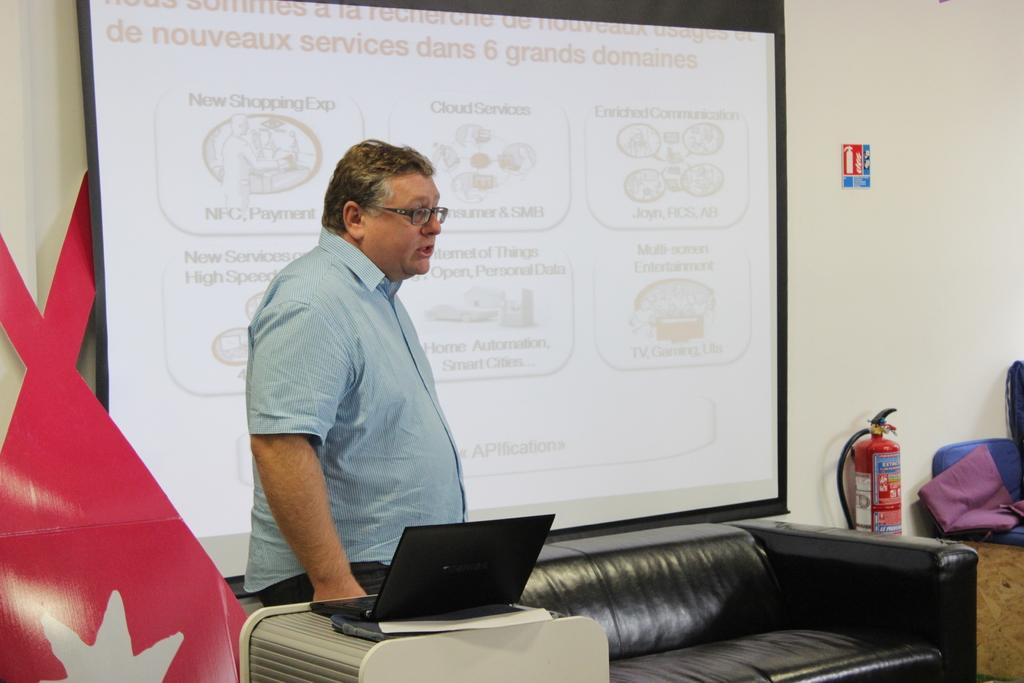Who is present in the image? There is a man in the image. What is the man doing in the image? The man is standing in the image. What object can be seen on the table in the image? There is a laptop on the table in the image. What type of robin can be seen sitting on the laptop in the image? There is no robin present in the image, and the laptop is not mentioned as having any object on it. 